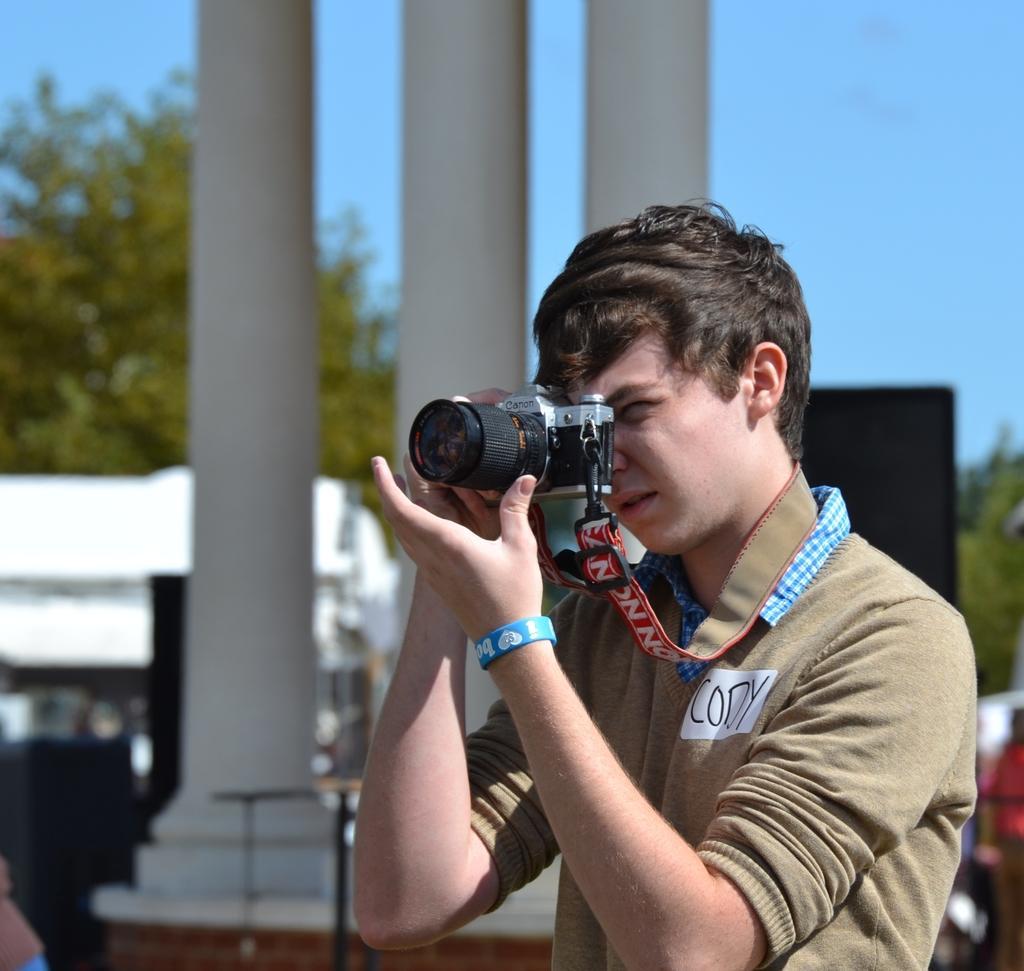Can you describe this image briefly? Here we can see a person capturing something with a camera in his hand and behind him we can see pillars and trees present 